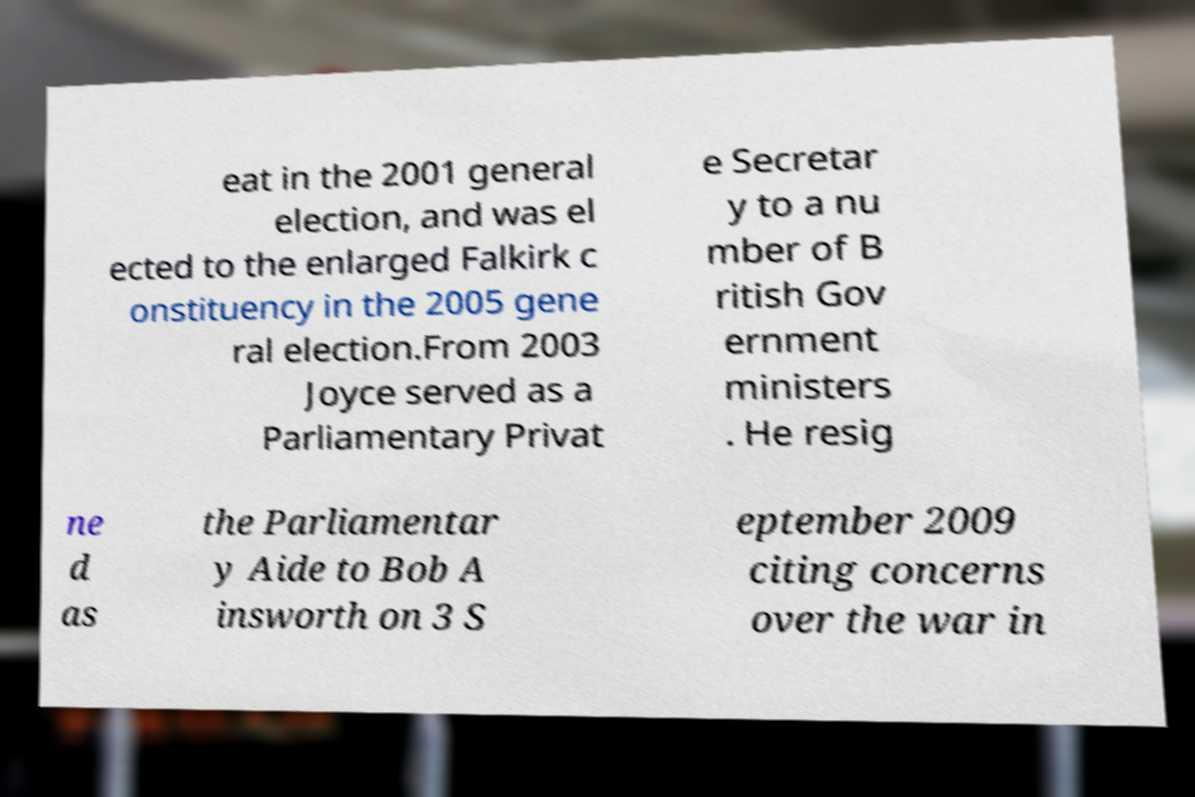Could you extract and type out the text from this image? eat in the 2001 general election, and was el ected to the enlarged Falkirk c onstituency in the 2005 gene ral election.From 2003 Joyce served as a Parliamentary Privat e Secretar y to a nu mber of B ritish Gov ernment ministers . He resig ne d as the Parliamentar y Aide to Bob A insworth on 3 S eptember 2009 citing concerns over the war in 